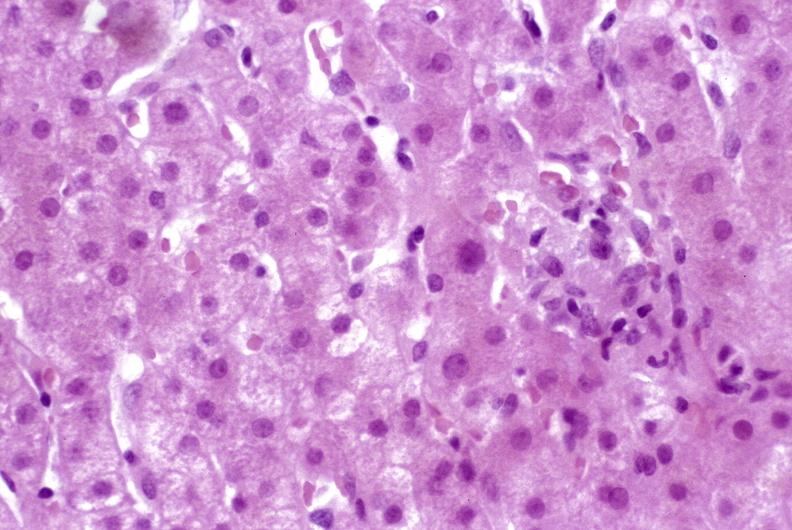does polysplenia show granulomas?
Answer the question using a single word or phrase. No 